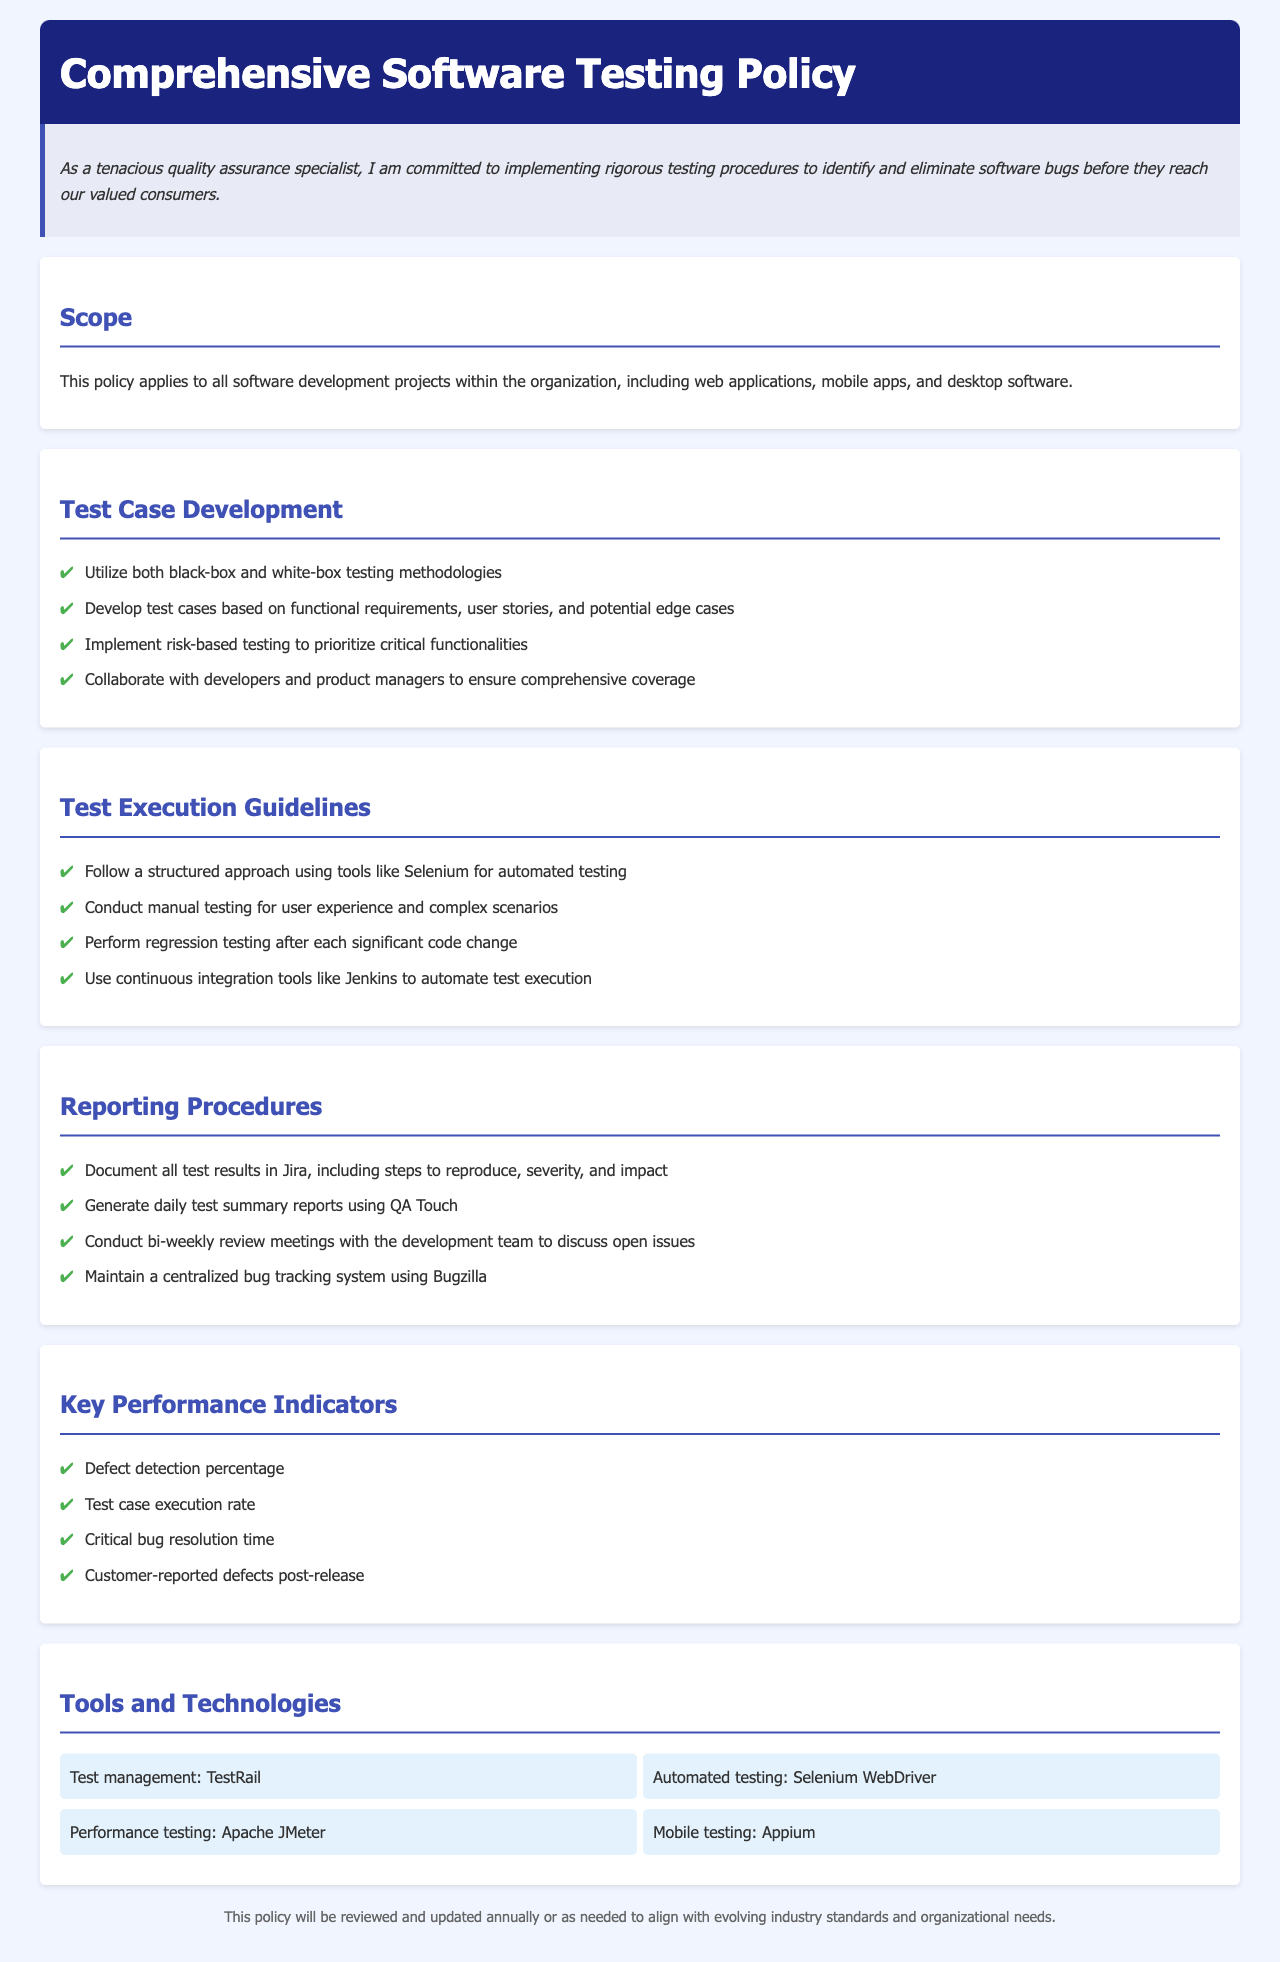What is the title of the document? The title is clearly stated at the top of the document.
Answer: Comprehensive Software Testing Policy What is the purpose of the policy statement? The purpose is stated in the introductory sentence.
Answer: Committed to implementing rigorous testing procedures Which methodologies should be used for test case development? The document outlines specific methodologies for developing test cases.
Answer: Black-box and white-box testing methodologies What should be documented in Jira according to the reporting procedures? The reporting procedures specify what information needs to be documented.
Answer: All test results including steps to reproduce, severity, and impact What are the four key performance indicators listed? The document specifically enumerates these indicators under a designated section.
Answer: Defect detection percentage, test case execution rate, critical bug resolution time, customer-reported defects post-release What tool is used for automated testing? The document mentions specific tools under the tools and technologies section.
Answer: Selenium WebDriver How often will the policy be reviewed? The document describes the frequency of policy reviews in the footer.
Answer: Annually What is the purpose of bi-weekly review meetings? The reporting procedures outline the purpose of these meetings.
Answer: Discuss open issues Which tool is mentioned for mobile testing? The tools and technologies section lists specific testing tools.
Answer: Appium 